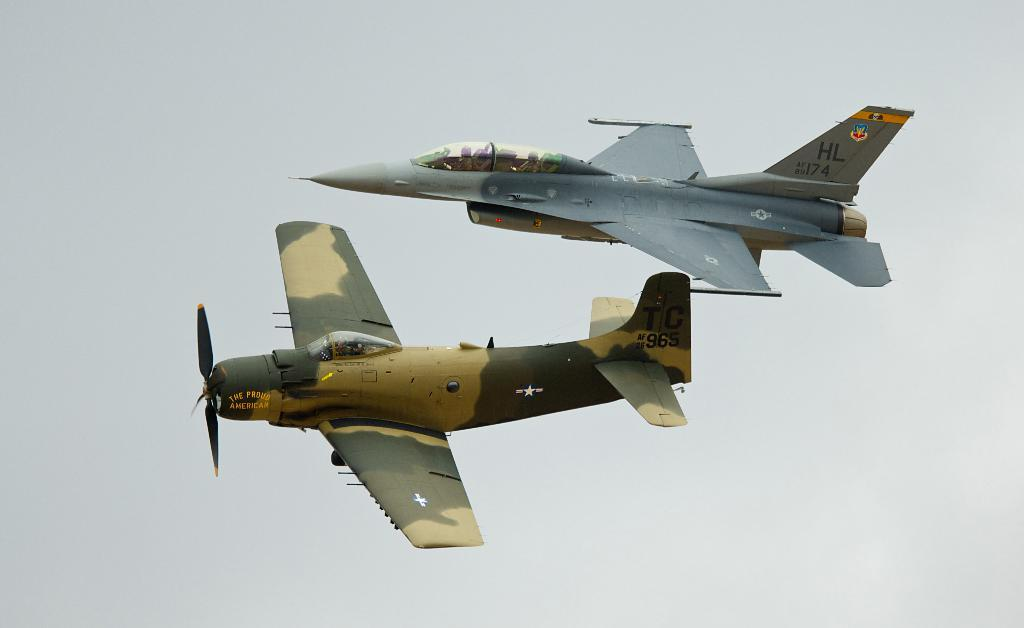<image>
Write a terse but informative summary of the picture. two planes and one with the letter HL on the back 